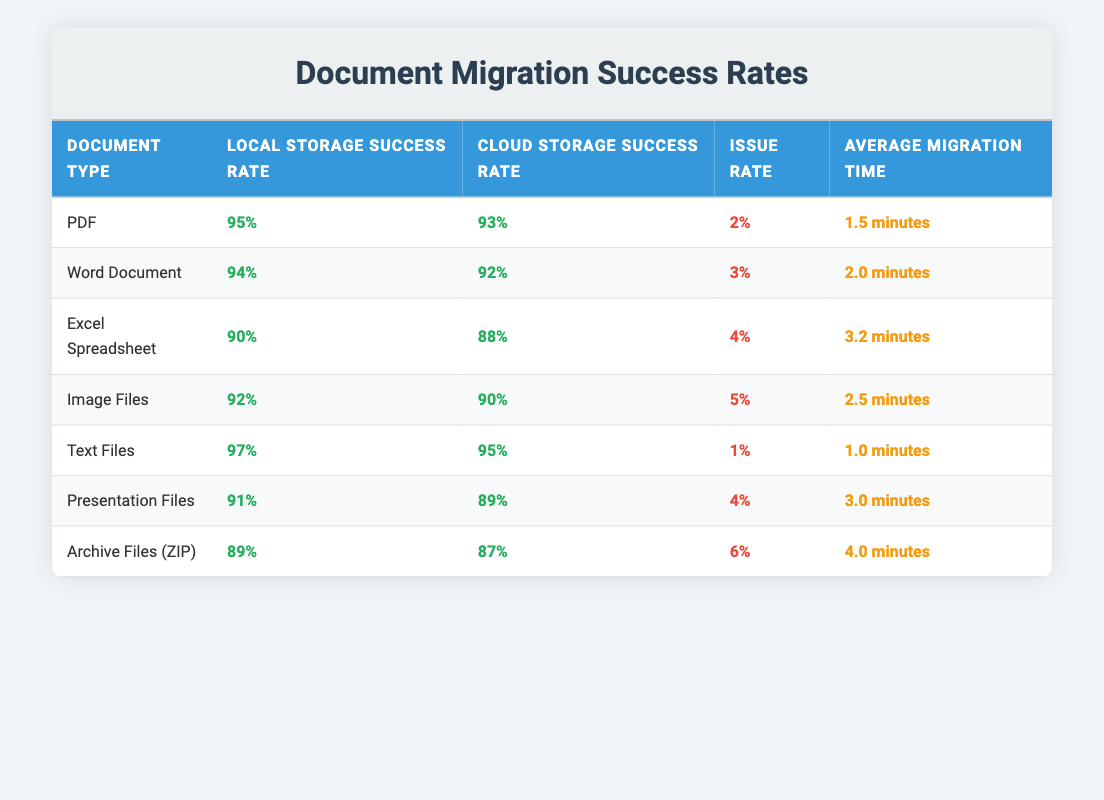What is the local storage success rate for Excel Spreadsheets? According to the table, the local storage success rate for Excel Spreadsheets is listed under the relevant row. It shows a percentage value of 90%.
Answer: 90% What document type has the highest local storage success rate? The table presents the local storage success rates for each document type. By examining these values, we can see that Text Files have the highest local storage success rate at 97%.
Answer: Text Files What is the average migration time for all document types? To find the average migration time, we take the sum of the migration times and divide by the number of document types. The migration times are: 1.5, 2.0, 3.2, 2.5, 1.0, 3.0, and 4.0 minutes. The sum is 1.5 + 2.0 + 3.2 + 2.5 + 1.0 + 3.0 + 4.0 = 17.2 minutes. There are 7 document types, so the average is 17.2 / 7 ≈ 2.46 minutes.
Answer: 2.46 minutes Is the issue rate for Archive Files higher than that for Presentation Files? The table shows the issue rate for Archive Files as 6% and for Presentation Files as 4%. Since 6% is greater than 4%, we can conclude that the issue rate for Archive Files is indeed higher.
Answer: Yes What is the difference between the cloud storage success rate of Image Files and Excel Spreadsheets? The cloud storage success rate for Image Files is 90% and for Excel Spreadsheets, it is 88%. To find the difference, subtract the cloud success rate of Excel Spreadsheets from that of Image Files: 90% - 88% = 2%.
Answer: 2% Which document types have a migration success rate of 90% or higher in cloud storage? By reviewing the table, we identify the cloud storage success rates for all document types. The ones with 90% or higher are PDF (93%), Text Files (95%), and Image Files (90%).
Answer: PDF, Text Files, Image Files What is the combined issue rate for Word Documents and Excel Spreadsheets? The issue rate for Word Documents is 3% and for Excel Spreadsheets it is 4%. To get the combined rate, add these two values: 3% + 4% = 7%.
Answer: 7% Does any document type have an average migration time of more than 3 minutes? Looking through the average migration times listed in the table, we see that only Archive Files has an average migration time of 4.0 minutes, which is indeed greater than 3 minutes.
Answer: Yes What is the cloud storage success rate for Text Files compared to the average cloud storage success rate across all document types? The cloud storage success rate for Text Files is 95%. The average cloud storage success rate can be calculated by adding all cloud storage success rates (93, 92, 88, 90, 95, 89, 87) and dividing by 7. This gives us an average of 90.14%. Comparing these, 95% is higher than the average.
Answer: Text Files is higher than average 